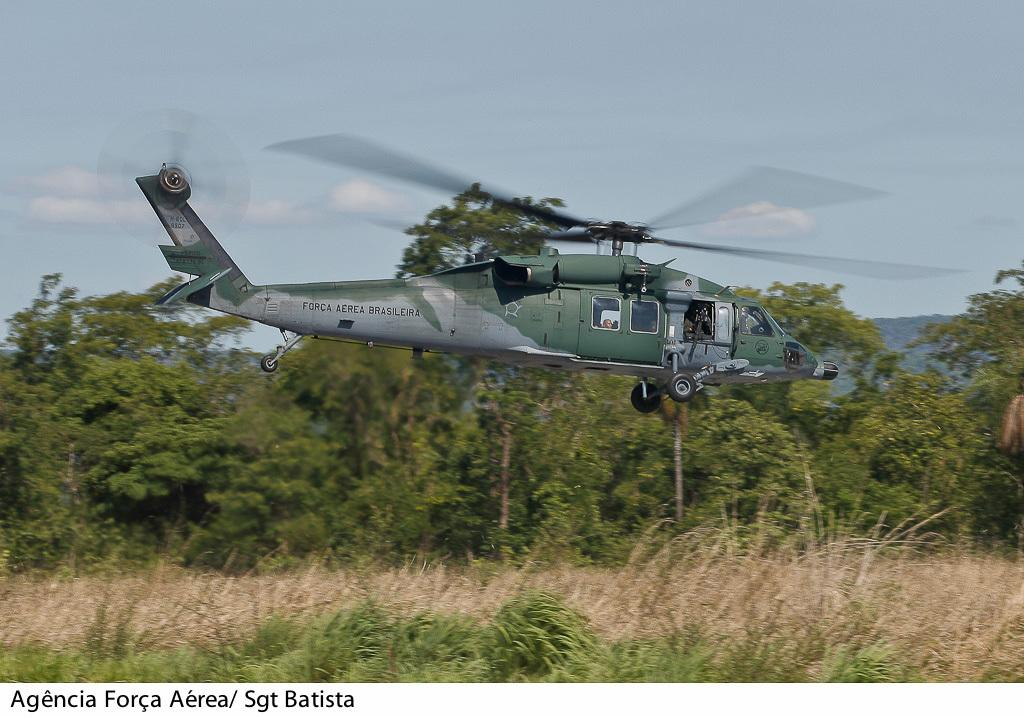What is the main subject of the image? The main subject of the image is an aircraft. Where is the aircraft located in the image? The aircraft is in the air. What can be seen in the background of the image? There is a group of trees and plants visible behind the aircraft. What is visible at the top of the image? The sky is visible at the top of the image. What is present in the bottom left corner of the image? There is some text in the bottom left corner of the image. How many birds are sitting on the fork in the image? There is no fork present in the image, and therefore no birds can be seen sitting on it. 